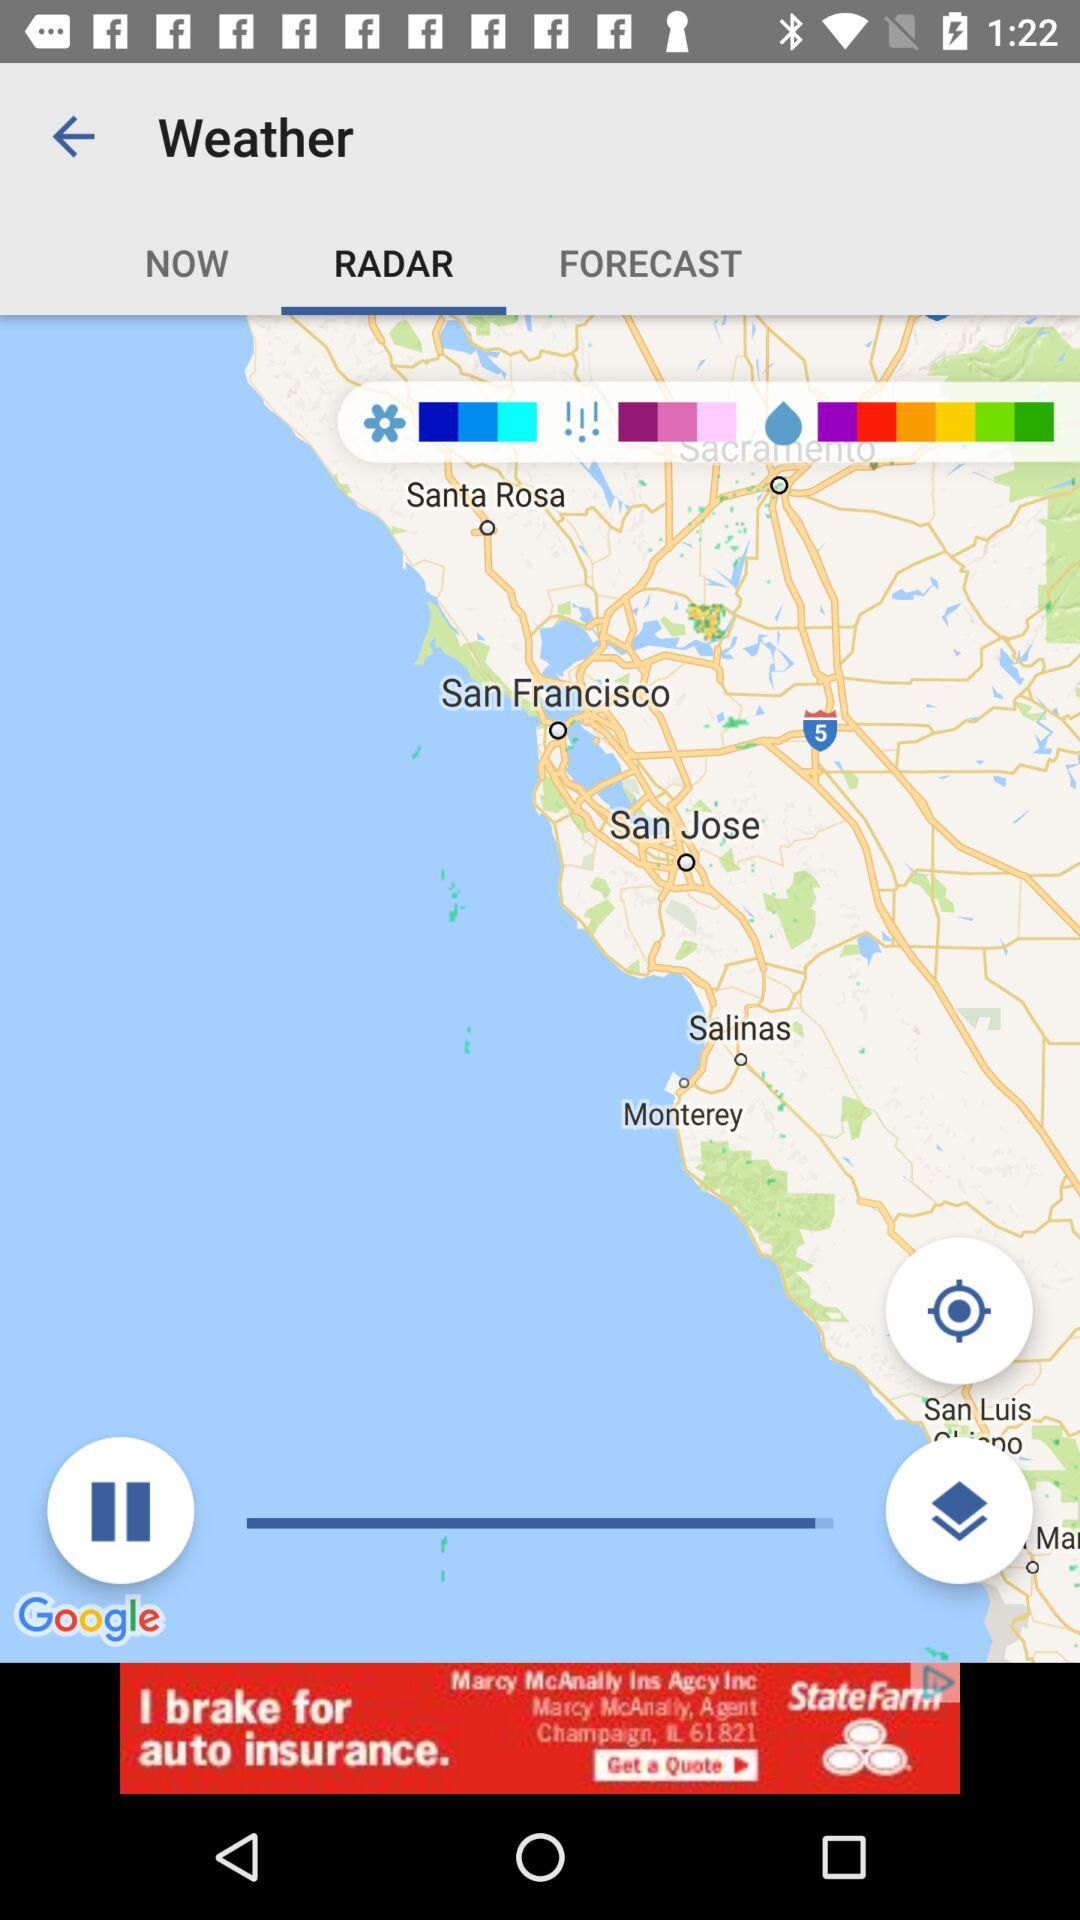Which tab am I now on? You are now on the "RADAR" tab. 